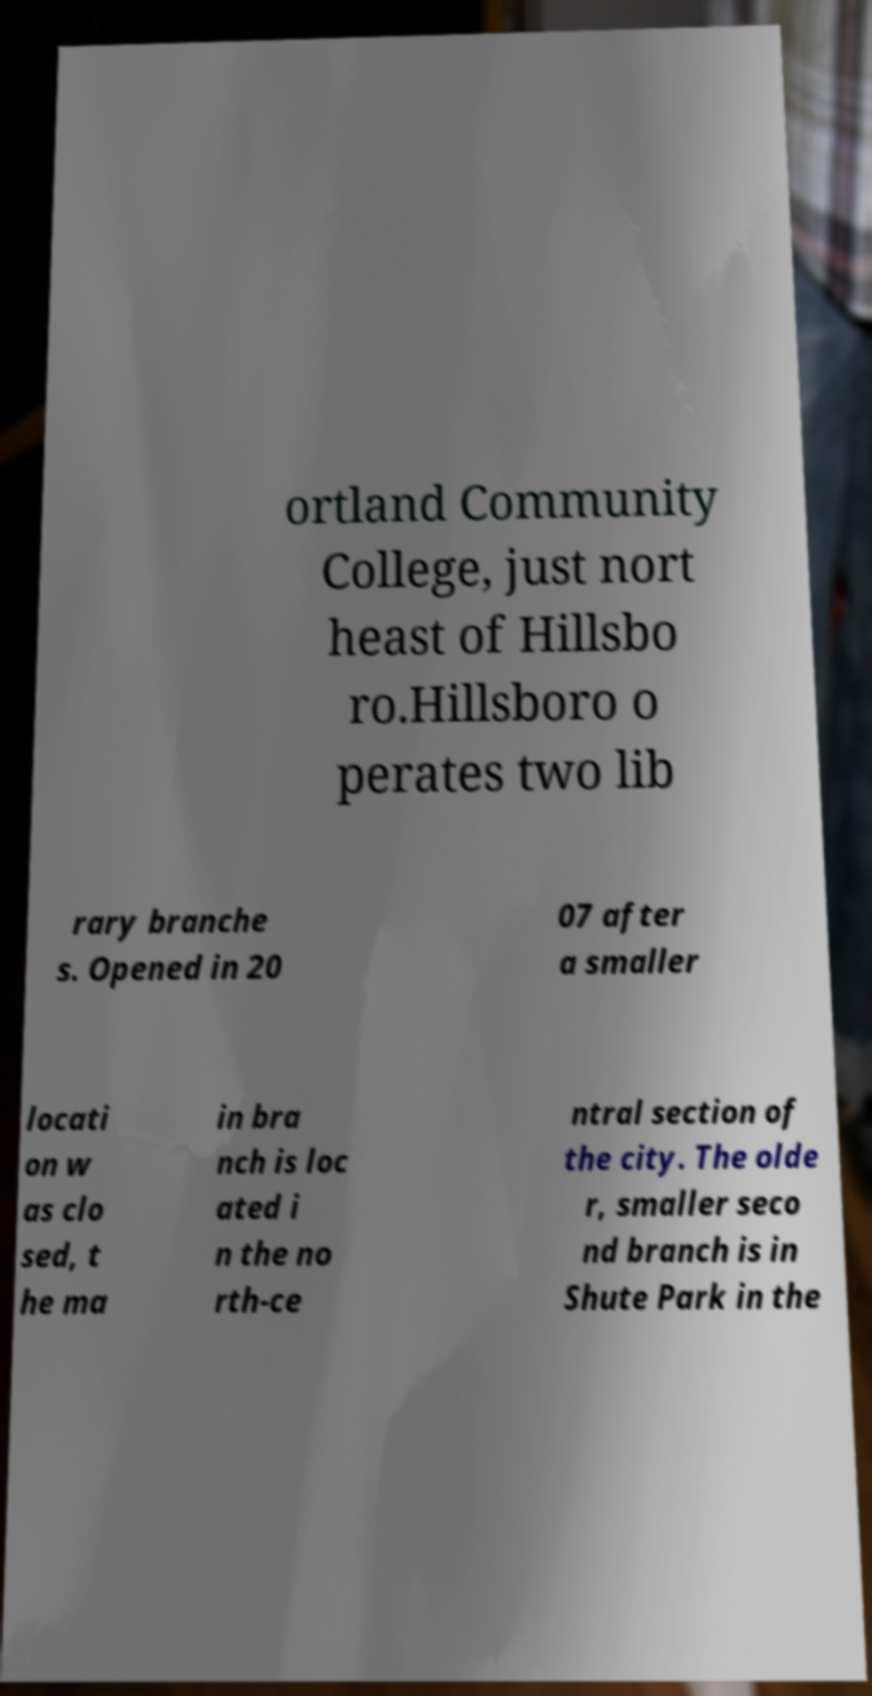What messages or text are displayed in this image? I need them in a readable, typed format. ortland Community College, just nort heast of Hillsbo ro.Hillsboro o perates two lib rary branche s. Opened in 20 07 after a smaller locati on w as clo sed, t he ma in bra nch is loc ated i n the no rth-ce ntral section of the city. The olde r, smaller seco nd branch is in Shute Park in the 